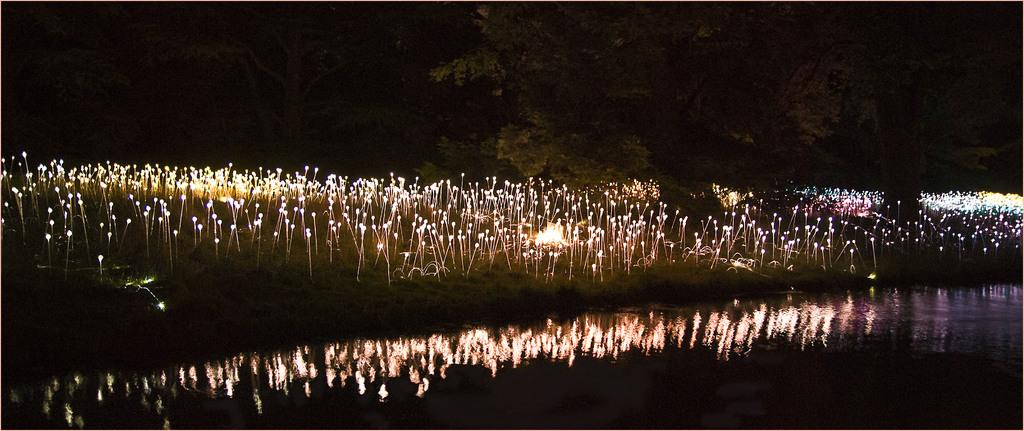What type of vegetation can be seen in the image? There are trees in the image. What natural element is visible in the image? There is water visible in the image. What type of artificial light is present in the image? There are lights in the image. How would you describe the overall lighting condition in the image? The image is described as being "little bit dark." What type of bread can be seen in the image? There is no bread present in the image. How many houses are visible in the image? There is no mention of houses in the image; it features trees, water, and lights. 